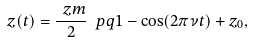<formula> <loc_0><loc_0><loc_500><loc_500>z ( t ) = \frac { \ z m } { 2 } \ p q { 1 - \cos ( 2 \pi \nu t ) } + z _ { 0 } ,</formula> 